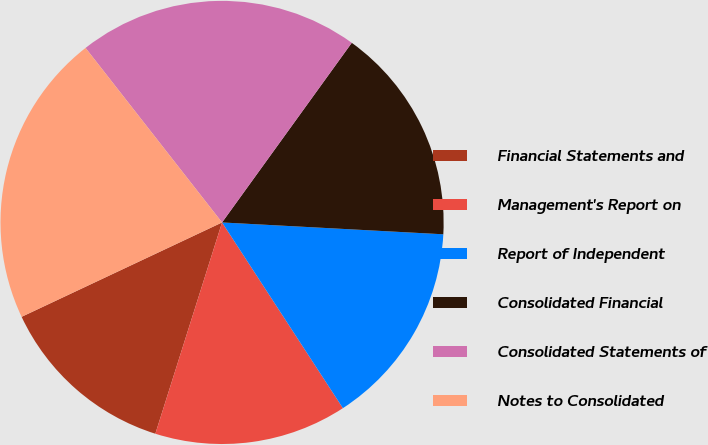<chart> <loc_0><loc_0><loc_500><loc_500><pie_chart><fcel>Financial Statements and<fcel>Management's Report on<fcel>Report of Independent<fcel>Consolidated Financial<fcel>Consolidated Statements of<fcel>Notes to Consolidated<nl><fcel>13.13%<fcel>14.05%<fcel>14.97%<fcel>15.9%<fcel>20.52%<fcel>21.44%<nl></chart> 